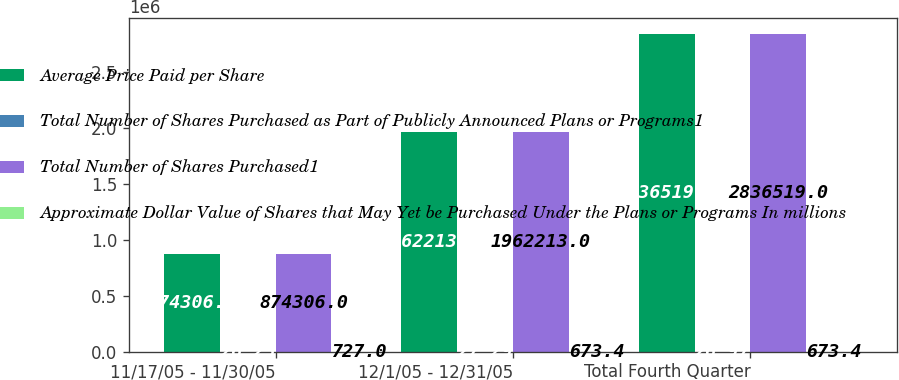Convert chart to OTSL. <chart><loc_0><loc_0><loc_500><loc_500><stacked_bar_chart><ecel><fcel>11/17/05 - 11/30/05<fcel>12/1/05 - 12/31/05<fcel>Total Fourth Quarter<nl><fcel>Average Price Paid per Share<fcel>874306<fcel>1.96221e+06<fcel>2.83652e+06<nl><fcel>Total Number of Shares Purchased as Part of Publicly Announced Plans or Programs1<fcel>26.25<fcel>27.29<fcel>26.97<nl><fcel>Total Number of Shares Purchased1<fcel>874306<fcel>1.96221e+06<fcel>2.83652e+06<nl><fcel>Approximate Dollar Value of Shares that May Yet be Purchased Under the Plans or Programs In millions<fcel>727<fcel>673.4<fcel>673.4<nl></chart> 